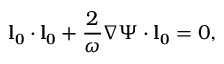<formula> <loc_0><loc_0><loc_500><loc_500>l _ { 0 } \cdot l _ { 0 } + \frac { 2 } { \omega } \nabla \Psi \cdot l _ { 0 } = 0 ,</formula> 